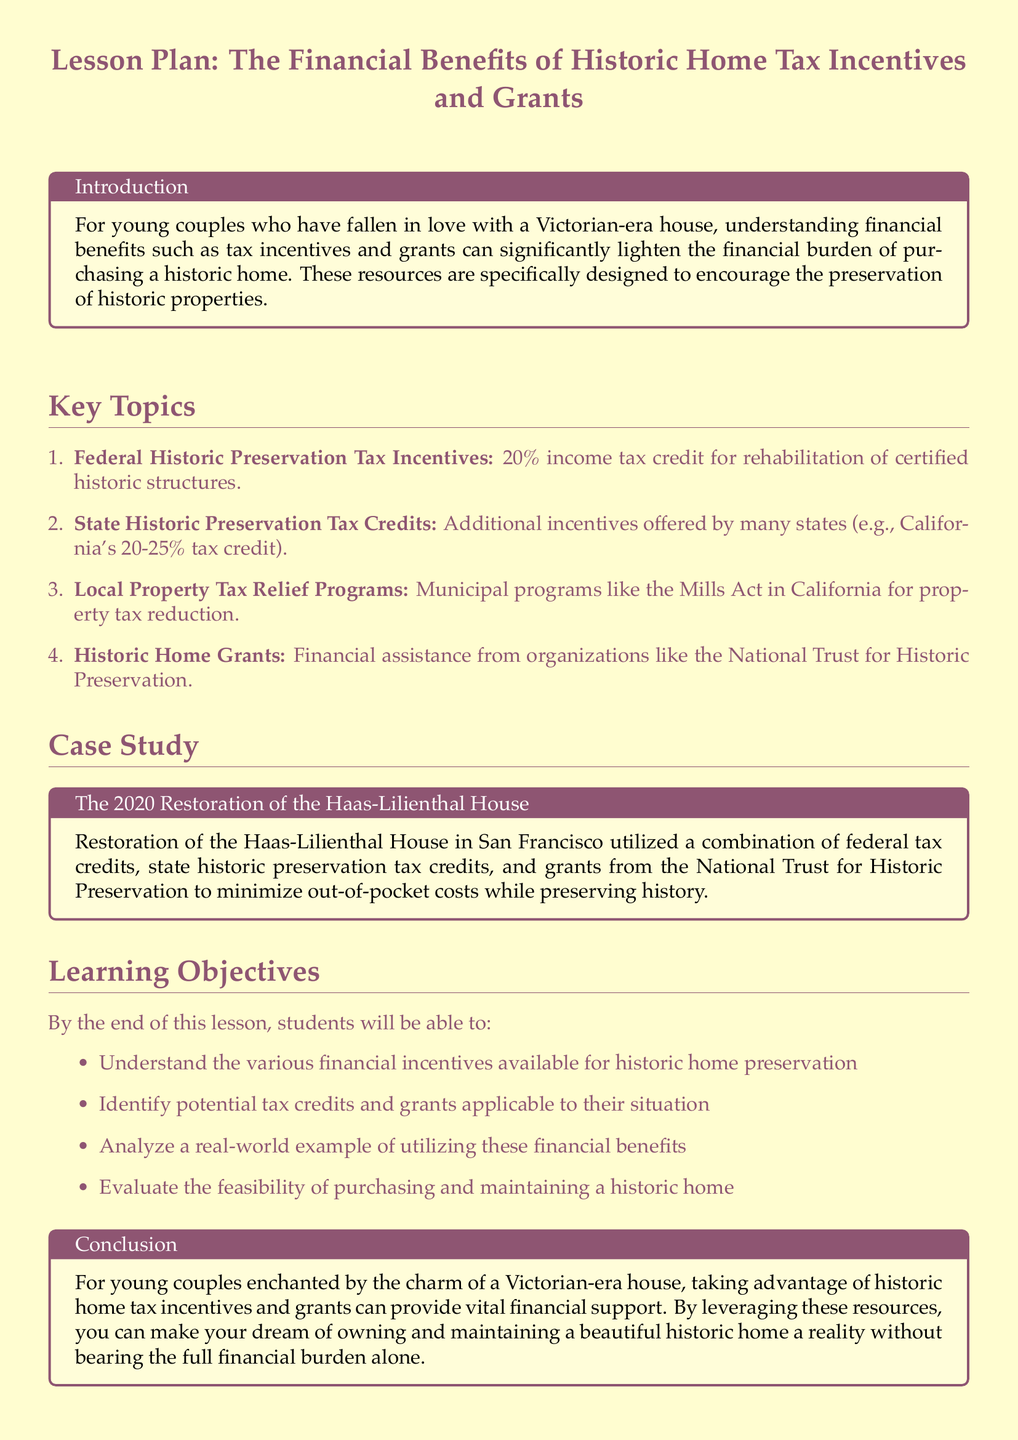What is the percentage of federal historic preservation tax incentives? The document states that there is a 20% income tax credit for rehabilitation of certified historic structures under federal historic preservation tax incentives.
Answer: 20% What are the additional incentives offered by California? The text mentions California's 20-25% tax credit as additional state historic preservation tax credits.
Answer: 20-25% What is the Mills Act? The Mills Act is referenced as a municipal program in California for property tax reduction, related to local property tax relief programs.
Answer: Property tax reduction Who provides financial assistance through historic home grants? According to the document, organizations like the National Trust for Historic Preservation provide financial assistance through historic home grants.
Answer: National Trust for Historic Preservation What is the main goal of this lesson plan? The lesson plan primarily aims to educate young couples on the financial benefits of historic home tax incentives and grants related to purchasing a historic home.
Answer: Financial benefits Which house's restoration is used as a case study? The Haas-Lilienthal House in San Francisco is cited as a case study within the document.
Answer: Haas-Lilienthal House What is the expected outcome of this lesson for students? Students are expected to understand the various financial incentives available for historic home preservation by the end of the lesson.
Answer: Understand financial incentives What type of document is this? The document is a lesson plan focused on financial benefits related to historic homes, targeted toward young couples interested in purchasing such properties.
Answer: Lesson plan 